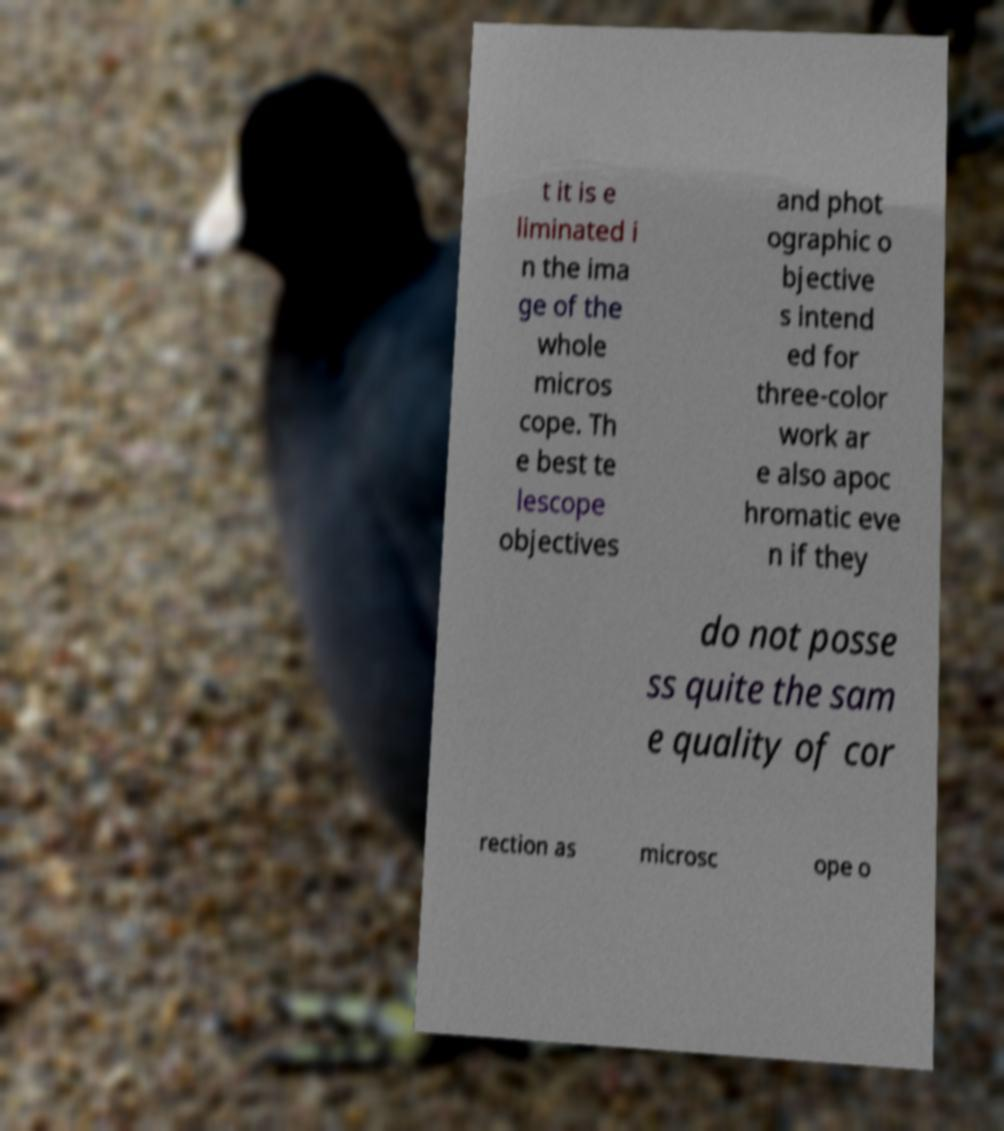Please identify and transcribe the text found in this image. t it is e liminated i n the ima ge of the whole micros cope. Th e best te lescope objectives and phot ographic o bjective s intend ed for three-color work ar e also apoc hromatic eve n if they do not posse ss quite the sam e quality of cor rection as microsc ope o 